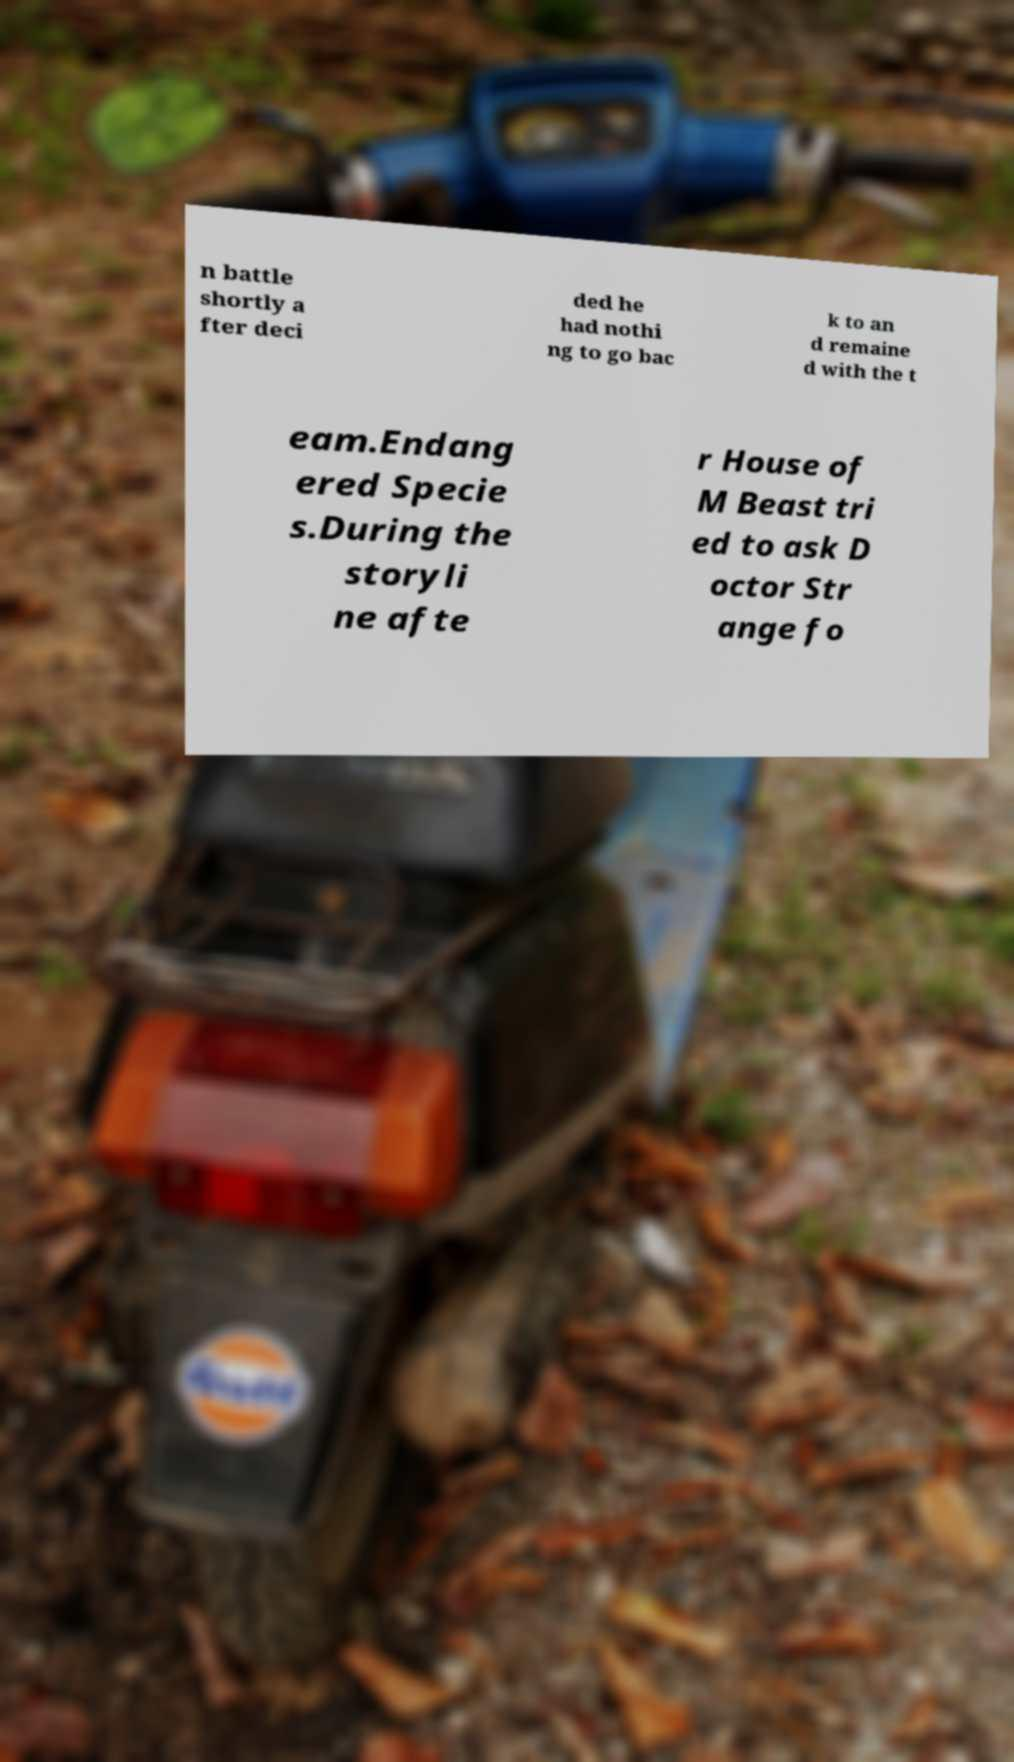Please identify and transcribe the text found in this image. n battle shortly a fter deci ded he had nothi ng to go bac k to an d remaine d with the t eam.Endang ered Specie s.During the storyli ne afte r House of M Beast tri ed to ask D octor Str ange fo 